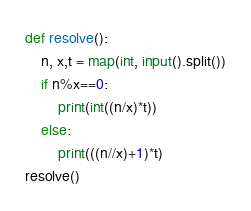Convert code to text. <code><loc_0><loc_0><loc_500><loc_500><_Python_>def resolve():
    n, x,t = map(int, input().split())
    if n%x==0:
        print(int((n/x)*t))
    else:
        print(((n//x)+1)*t)
resolve()</code> 